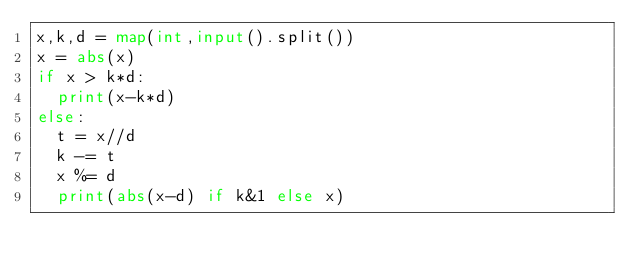Convert code to text. <code><loc_0><loc_0><loc_500><loc_500><_Python_>x,k,d = map(int,input().split())
x = abs(x)
if x > k*d:
  print(x-k*d)
else:
  t = x//d
  k -= t
  x %= d
  print(abs(x-d) if k&1 else x)</code> 